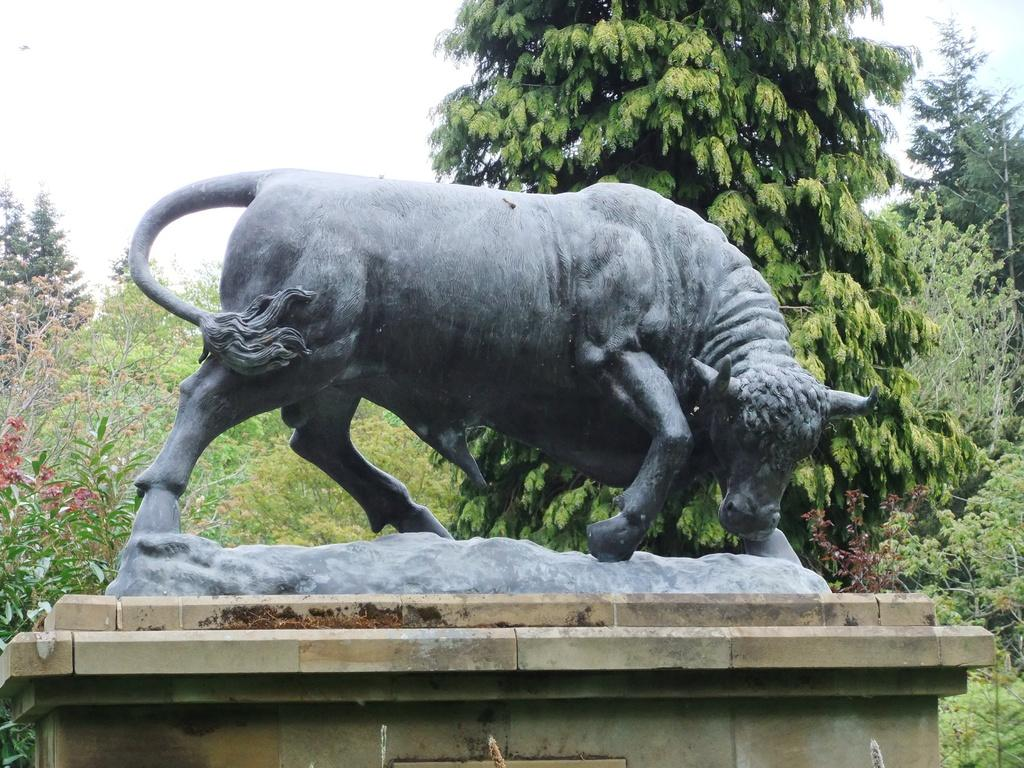What is the main subject of the image? There is a statue in the image. Where is the statue located? The statue is on a pillar. What can be seen in the background of the image? There are plants and trees visible in the background of the image. What type of thumb is being displayed by the statue in the image? There is no thumb visible on the statue in the image. How does the statue express disgust in the image? The statue does not express any emotions, including disgust, in the image. 